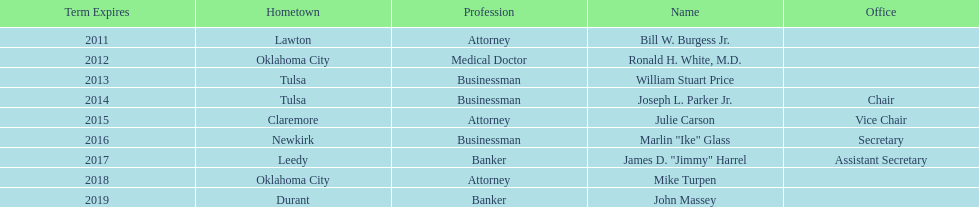Which state regent's term will last the longest? John Massey. 